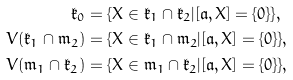Convert formula to latex. <formula><loc_0><loc_0><loc_500><loc_500>\mathfrak { k } _ { 0 } & = \{ X \in \mathfrak { k } _ { 1 } \cap \mathfrak { k } _ { 2 } | [ \mathfrak { a } , X ] = \{ 0 \} \} , \\ V ( \mathfrak { k } _ { 1 } \cap \mathfrak { m } _ { 2 } ) & = \{ X \in \mathfrak { k } _ { 1 } \cap \mathfrak { m } _ { 2 } | [ \mathfrak { a } , X ] = \{ 0 \} \} , \\ V ( \mathfrak { m } _ { 1 } \cap \mathfrak { k } _ { 2 } ) & = \{ X \in \mathfrak { m } _ { 1 } \cap \mathfrak { k } _ { 2 } | [ \mathfrak { a } , X ] = \{ 0 \} \} ,</formula> 